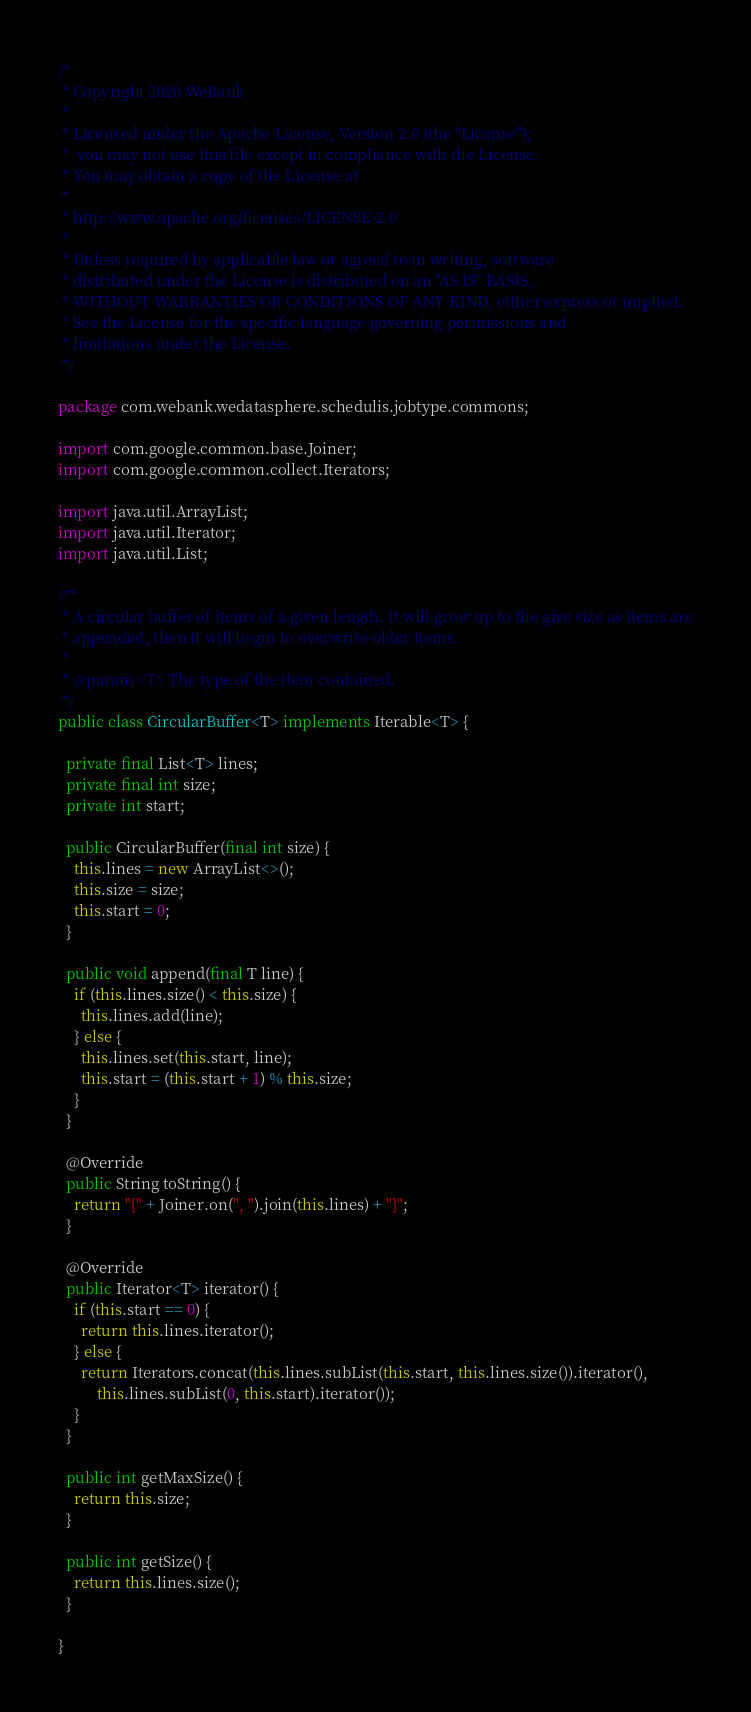Convert code to text. <code><loc_0><loc_0><loc_500><loc_500><_Java_>/*
 * Copyright 2020 WeBank
 *
 * Licensed under the Apache License, Version 2.0 (the "License");
 *  you may not use this file except in compliance with the License.
 * You may obtain a copy of the License at
 *
 * http://www.apache.org/licenses/LICENSE-2.0
 *
 * Unless required by applicable law or agreed to in writing, software
 * distributed under the License is distributed on an "AS IS" BASIS,
 * WITHOUT WARRANTIES OR CONDITIONS OF ANY KIND, either express or implied.
 * See the License for the specific language governing permissions and
 * limitations under the License.
 */

package com.webank.wedatasphere.schedulis.jobtype.commons;

import com.google.common.base.Joiner;
import com.google.common.collect.Iterators;

import java.util.ArrayList;
import java.util.Iterator;
import java.util.List;

/**
 * A circular buffer of items of a given length. It will grow up to the give size as items are
 * appended, then it will begin to overwrite older items.
 *
 * @param <T> The type of the item contained.
 */
public class CircularBuffer<T> implements Iterable<T> {

  private final List<T> lines;
  private final int size;
  private int start;

  public CircularBuffer(final int size) {
    this.lines = new ArrayList<>();
    this.size = size;
    this.start = 0;
  }

  public void append(final T line) {
    if (this.lines.size() < this.size) {
      this.lines.add(line);
    } else {
      this.lines.set(this.start, line);
      this.start = (this.start + 1) % this.size;
    }
  }

  @Override
  public String toString() {
    return "[" + Joiner.on(", ").join(this.lines) + "]";
  }

  @Override
  public Iterator<T> iterator() {
    if (this.start == 0) {
      return this.lines.iterator();
    } else {
      return Iterators.concat(this.lines.subList(this.start, this.lines.size()).iterator(),
          this.lines.subList(0, this.start).iterator());
    }
  }

  public int getMaxSize() {
    return this.size;
  }

  public int getSize() {
    return this.lines.size();
  }

}
</code> 